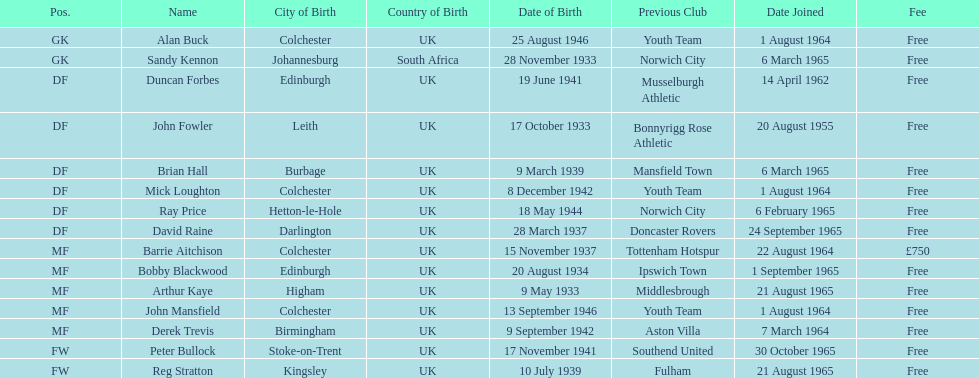Could you parse the entire table as a dict? {'header': ['Pos.', 'Name', 'City of Birth', 'Country of Birth', 'Date of Birth', 'Previous Club', 'Date Joined', 'Fee'], 'rows': [['GK', 'Alan Buck', 'Colchester', 'UK', '25 August 1946', 'Youth Team', '1 August 1964', 'Free'], ['GK', 'Sandy Kennon', 'Johannesburg', 'South Africa', '28 November 1933', 'Norwich City', '6 March 1965', 'Free'], ['DF', 'Duncan Forbes', 'Edinburgh', 'UK', '19 June 1941', 'Musselburgh Athletic', '14 April 1962', 'Free'], ['DF', 'John Fowler', 'Leith', 'UK', '17 October 1933', 'Bonnyrigg Rose Athletic', '20 August 1955', 'Free'], ['DF', 'Brian Hall', 'Burbage', 'UK', '9 March 1939', 'Mansfield Town', '6 March 1965', 'Free'], ['DF', 'Mick Loughton', 'Colchester', 'UK', '8 December 1942', 'Youth Team', '1 August 1964', 'Free'], ['DF', 'Ray Price', 'Hetton-le-Hole', 'UK', '18 May 1944', 'Norwich City', '6 February 1965', 'Free'], ['DF', 'David Raine', 'Darlington', 'UK', '28 March 1937', 'Doncaster Rovers', '24 September 1965', 'Free'], ['MF', 'Barrie Aitchison', 'Colchester', 'UK', '15 November 1937', 'Tottenham Hotspur', '22 August 1964', '£750'], ['MF', 'Bobby Blackwood', 'Edinburgh', 'UK', '20 August 1934', 'Ipswich Town', '1 September 1965', 'Free'], ['MF', 'Arthur Kaye', 'Higham', 'UK', '9 May 1933', 'Middlesbrough', '21 August 1965', 'Free'], ['MF', 'John Mansfield', 'Colchester', 'UK', '13 September 1946', 'Youth Team', '1 August 1964', 'Free'], ['MF', 'Derek Trevis', 'Birmingham', 'UK', '9 September 1942', 'Aston Villa', '7 March 1964', 'Free'], ['FW', 'Peter Bullock', 'Stoke-on-Trent', 'UK', '17 November 1941', 'Southend United', '30 October 1965', 'Free'], ['FW', 'Reg Stratton', 'Kingsley', 'UK', '10 July 1939', 'Fulham', '21 August 1965', 'Free']]} Which team was ray price on before he started for this team? Norwich City. 